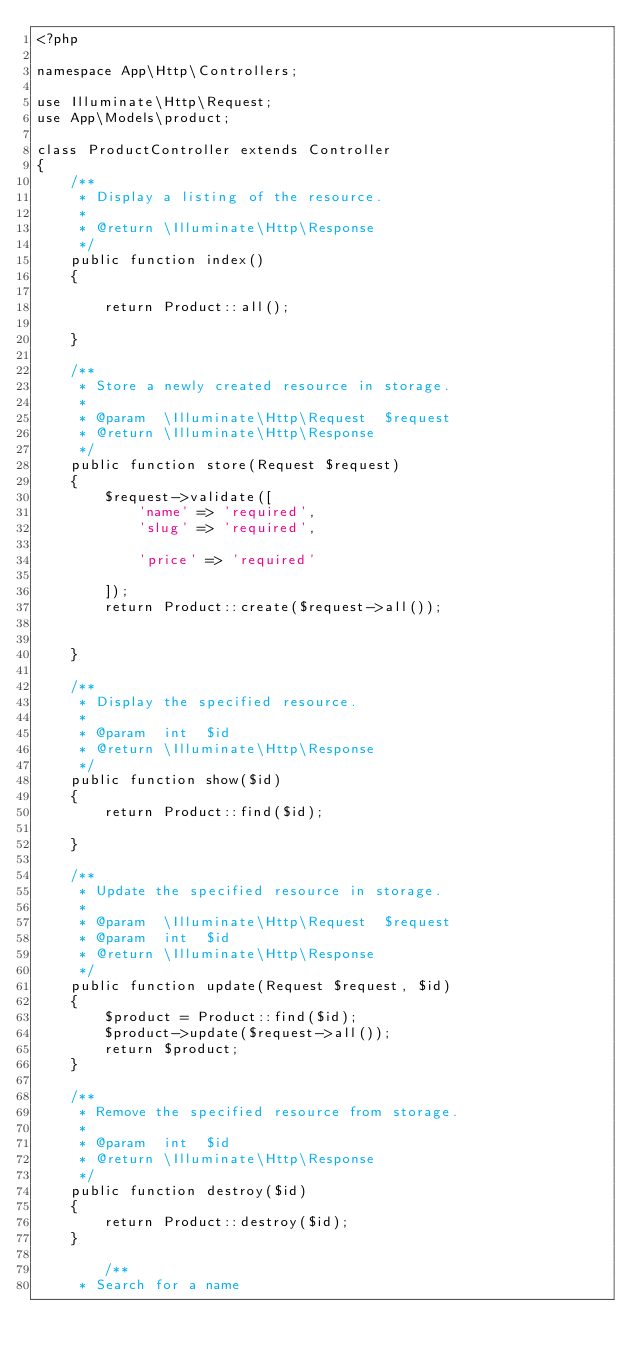<code> <loc_0><loc_0><loc_500><loc_500><_PHP_><?php

namespace App\Http\Controllers;

use Illuminate\Http\Request;
use App\Models\product;

class ProductController extends Controller
{
    /**
     * Display a listing of the resource.
     *
     * @return \Illuminate\Http\Response
     */
    public function index()
    {
        
        return Product::all();
        
    }

    /**
     * Store a newly created resource in storage.
     *
     * @param  \Illuminate\Http\Request  $request
     * @return \Illuminate\Http\Response
     */
    public function store(Request $request)
    {
        $request->validate([
            'name' => 'required',
            'slug' => 'required',
            
            'price' => 'required'
            
        ]);
        return Product::create($request->all());
            
      
    }

    /**
     * Display the specified resource.
     *
     * @param  int  $id
     * @return \Illuminate\Http\Response
     */
    public function show($id)
    {
        return Product::find($id);
        
    }

    /**
     * Update the specified resource in storage.
     *
     * @param  \Illuminate\Http\Request  $request
     * @param  int  $id
     * @return \Illuminate\Http\Response
     */
    public function update(Request $request, $id)
    {
        $product = Product::find($id);
        $product->update($request->all());
        return $product;
    }

    /**
     * Remove the specified resource from storage.
     *
     * @param  int  $id
     * @return \Illuminate\Http\Response
     */
    public function destroy($id)
    {
        return Product::destroy($id);
    }

        /**
     * Search for a name</code> 